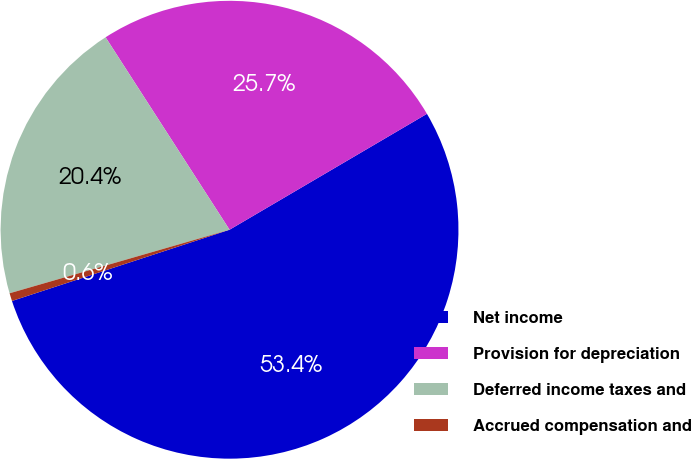<chart> <loc_0><loc_0><loc_500><loc_500><pie_chart><fcel>Net income<fcel>Provision for depreciation<fcel>Deferred income taxes and<fcel>Accrued compensation and<nl><fcel>53.42%<fcel>25.66%<fcel>20.37%<fcel>0.56%<nl></chart> 